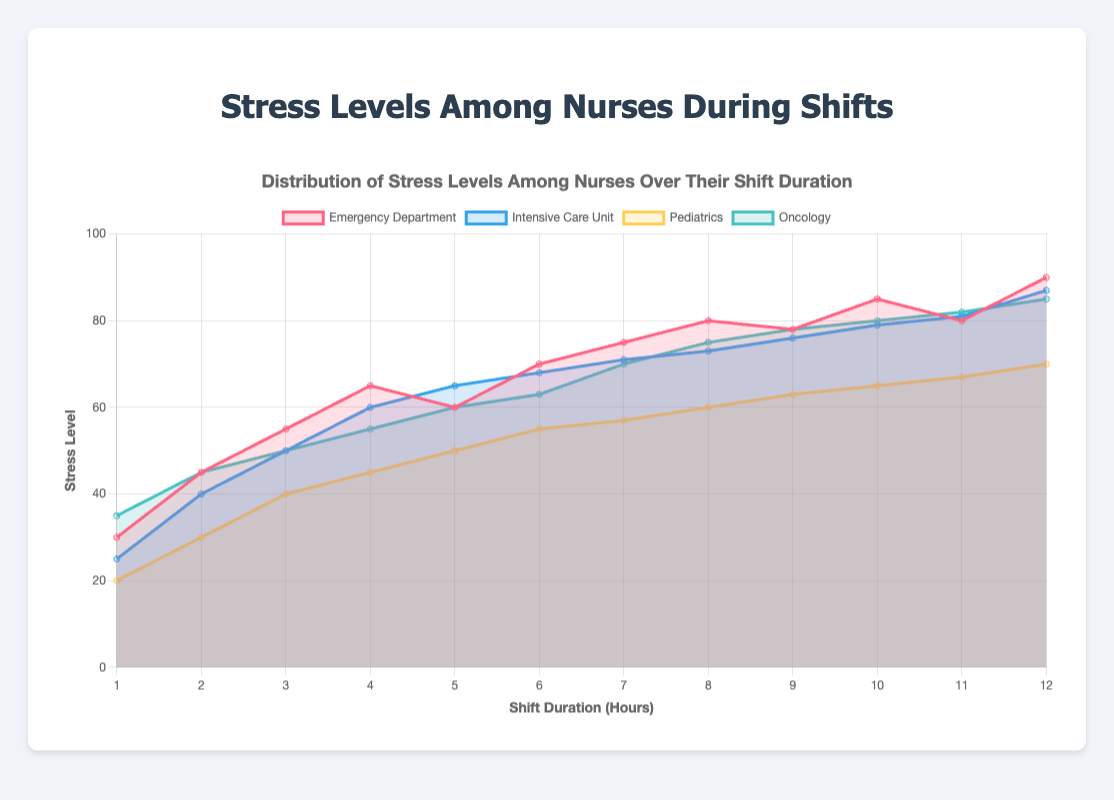Which department has the highest stress level at the 12th hour? Identify the stress levels for each department at the 12th hour: Emergency Department (90), Intensive Care Unit (87), Pediatrics (70), Oncology (85). The highest is Emergency Department at 90.
Answer: Emergency Department How does the stress level in the Intensive Care Unit change from the 1st hour to the 5th hour? Look at the stress levels for Intensive Care Unit from 1st to 5th hour: 25, 40, 50, 60, 65. It increases progressively.
Answer: Increases What is the difference in stress levels between Pediatrics and Emergency Department at the 6th hour? Compare the stress levels at the 6th hour: Pediatrics (55) and Emergency Department (70). The difference is 70 - 55 = 15.
Answer: 15 Which department has the lowest stress level at the beginning of the shift? Observe the stress levels at the 1st hour: Emergency Department (30), Intensive Care Unit (25), Pediatrics (20), Oncology (35). The lowest is Pediatrics at 20.
Answer: Pediatrics What trend can be observed in the Oncology department's stress levels over the shift duration? Analyze the stress levels trend in Oncology: 35, 45, 50, 55, 60, 63, 70, 75, 78, 80, 82, 85. The stress level overall increases.
Answer: Increases At the 9th hour, how do the stress levels compare across the four departments? Look at the stress levels at the 9th hour: Emergency Department (78), Intensive Care Unit (76), Pediatrics (63), Oncology (78). Emergency Department and Oncology are highest, followed by Intensive Care Unit, and then Pediatrics.
Answer: Emergency Department & Oncology > Intensive Care Unit > Pediatrics Find the average stress level for the Intensive Care Unit at the 3rd, 7th, and 11th hours combined. The stress levels at 3rd, 7th, and 11th hours are: 50, 71, 81. Sum them up: 50 + 71 + 81 = 202. Average is 202 / 3 = 67.33.
Answer: 67.33 Which hour marks the first instance where the Emergency Department's stress level reaches 80 or above? Review Emergency Department's stress levels hourly: 30, 45, 55, 65, 60, 70, 75, 80. The 8th hour is the first instance of reaching 80.
Answer: 8th hour What is the total increase in stress level for the Pediatrics department from the 1st to the 12th hour? Compare the stress levels at the 1st (20) and 12th hour (70): The increase is 70 - 20 = 50.
Answer: 50 